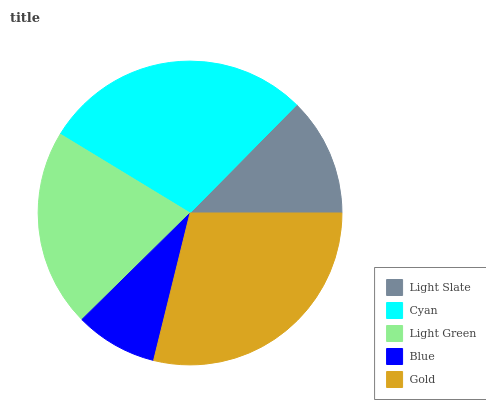Is Blue the minimum?
Answer yes or no. Yes. Is Gold the maximum?
Answer yes or no. Yes. Is Cyan the minimum?
Answer yes or no. No. Is Cyan the maximum?
Answer yes or no. No. Is Cyan greater than Light Slate?
Answer yes or no. Yes. Is Light Slate less than Cyan?
Answer yes or no. Yes. Is Light Slate greater than Cyan?
Answer yes or no. No. Is Cyan less than Light Slate?
Answer yes or no. No. Is Light Green the high median?
Answer yes or no. Yes. Is Light Green the low median?
Answer yes or no. Yes. Is Light Slate the high median?
Answer yes or no. No. Is Cyan the low median?
Answer yes or no. No. 